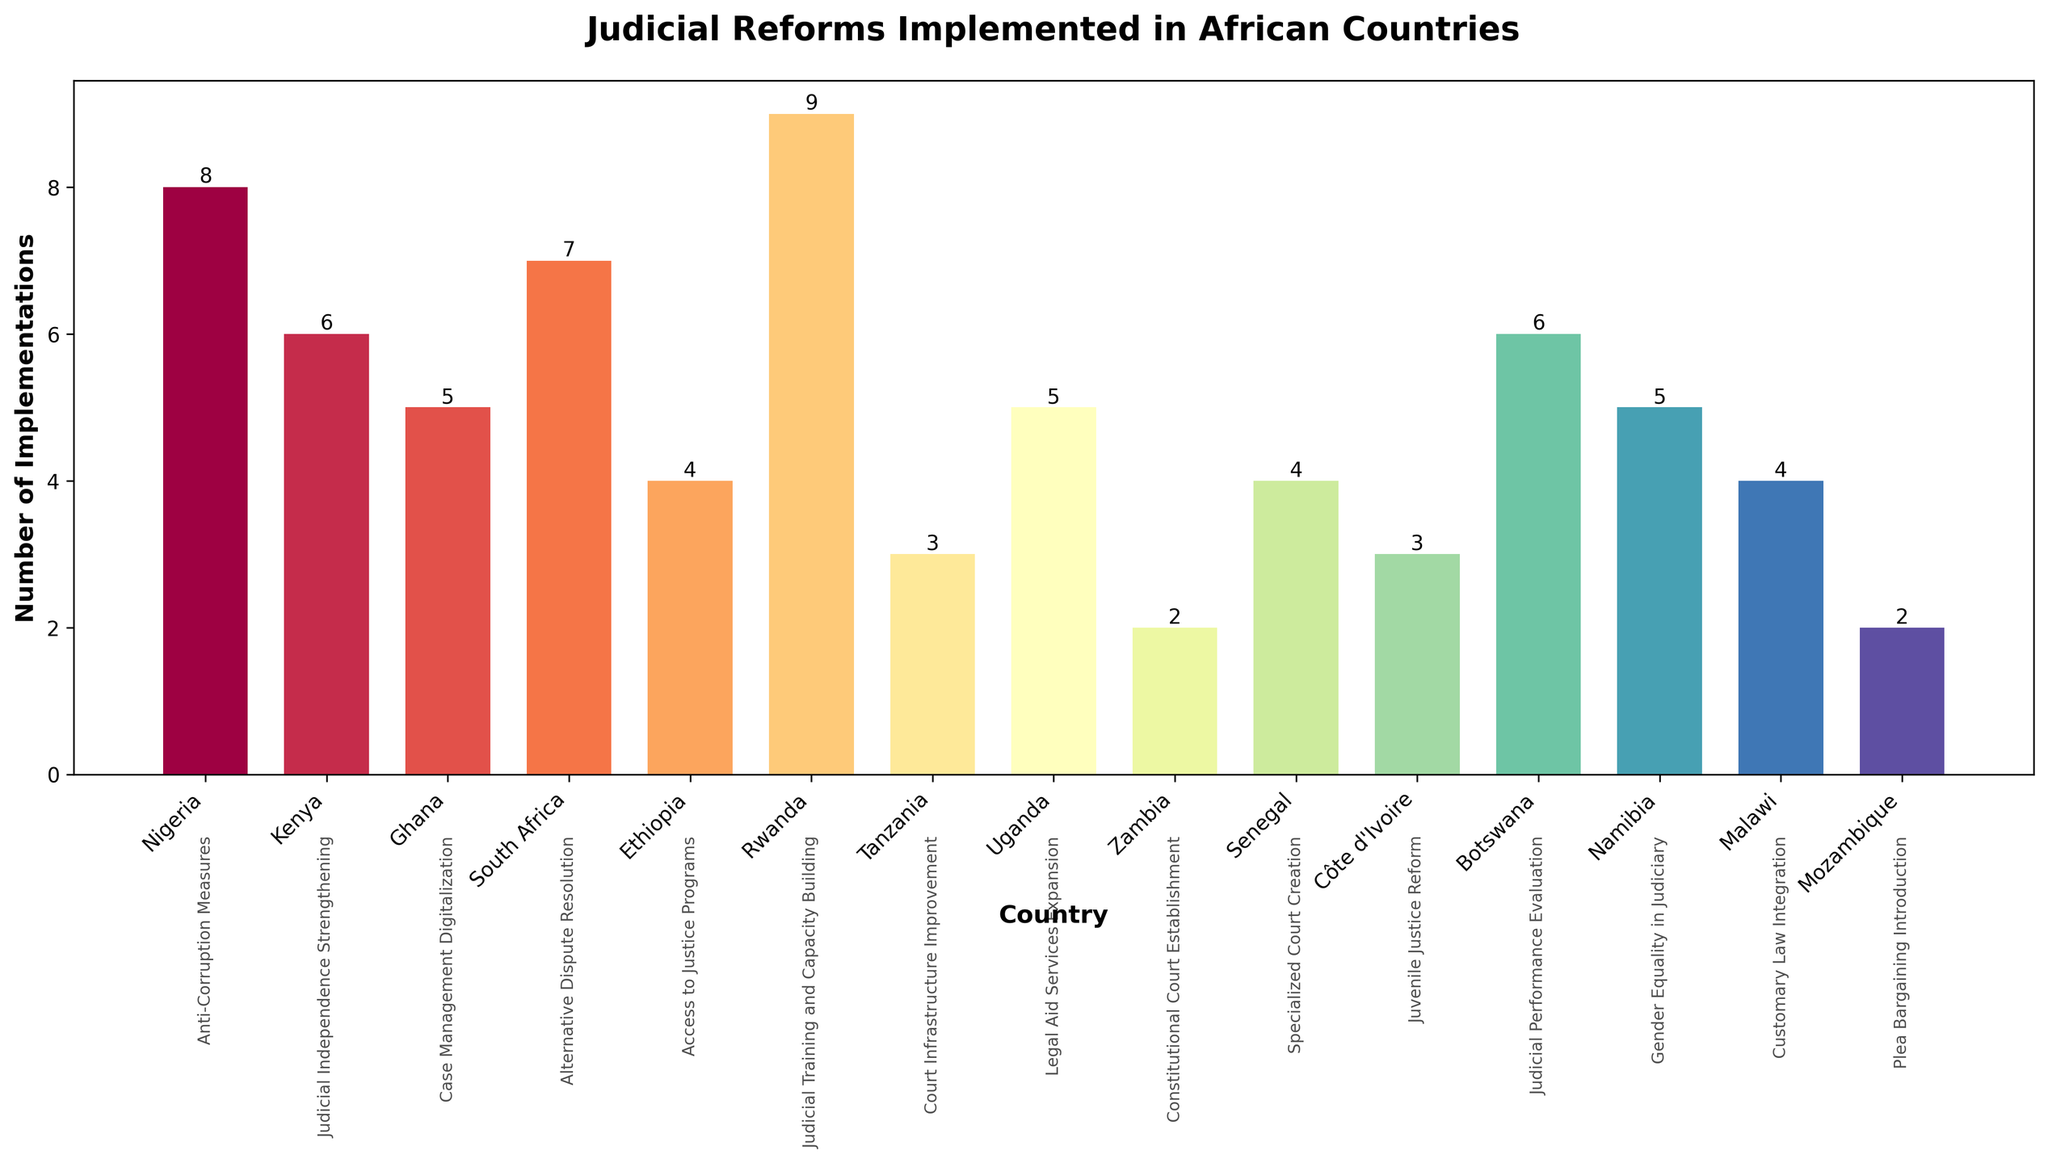What is the most implemented type of judicial reform? The bar for Rwanda, which is labeled with "Judicial Training and Capacity Building," has the highest value of 9 implementations visible on the y-axis.
Answer: Judicial Training and Capacity Building Which country implemented the fewest judicial reforms? The bars for Zambia and Mozambique both have the lowest value of 2 implementations, so both countries have implemented the fewest reforms.
Answer: Zambia and Mozambique Which country's judicial reforms focus on Anti-Corruption Measures, and how many implementations are there? The bar for Nigeria is labeled with "Anti-Corruption Measures," and it has a height corresponding to 8 implementations.
Answer: Nigeria with 8 implementations Compare the number of implementations between Kenya and Botswana. Which one has more, and by how many? Kenya has 6 implementations (Judicial Independence Strengthening), while Botswana has 6 implementations (Judicial Performance Evaluation). Both have the same number of implementations so the difference is 0.
Answer: They are equal by 0 What's the total number of implementations for Access to Justice Programs and Legal Aid Services Expansion reforms combined? Ethiopia's "Access to Justice Programs" has 4 implementations, and Uganda's "Legal Aid Services Expansion" has 5, so the total is 4 + 5 = 9 implementations.
Answer: 9 Which countries have implemented reforms related to gender equality and juvenile justice, and how many implementations are there in each? The bar for Namibia, labeled with "Gender Equality in Judiciary," shows 5 implementations; the bar for Côte d'Ivoire, labeled with "Juvenile Justice Reform," shows 3 implementations.
Answer: Namibia with 5, Côte d'Ivoire with 3 Are there more implementations of Case Management Digitalization than Alternative Dispute Resolution? By how many? Ghana has implemented "Case Management Digitalization" 5 times, while South Africa has implemented "Alternative Dispute Resolution" 7 times. Therefore, there are fewer implementations of Case Management Digitalization by 2.
Answer: No, by 2 less Which country implements the second-highest number of judicial reforms, and what is the reform type? The second highest bar belongs to South Africa with 7 implementations for "Alternative Dispute Resolution".
Answer: South Africa with Alternative Dispute Resolution What's the average number of implementations across all countries? Sum all implementations (8+6+5+7+4+9+3+5+2+4+3+6+5+4+2 = 73) and divide by the number of countries (15). So, the average is 73/15 ≈ 4.87 implementations.
Answer: Approximately 4.87 